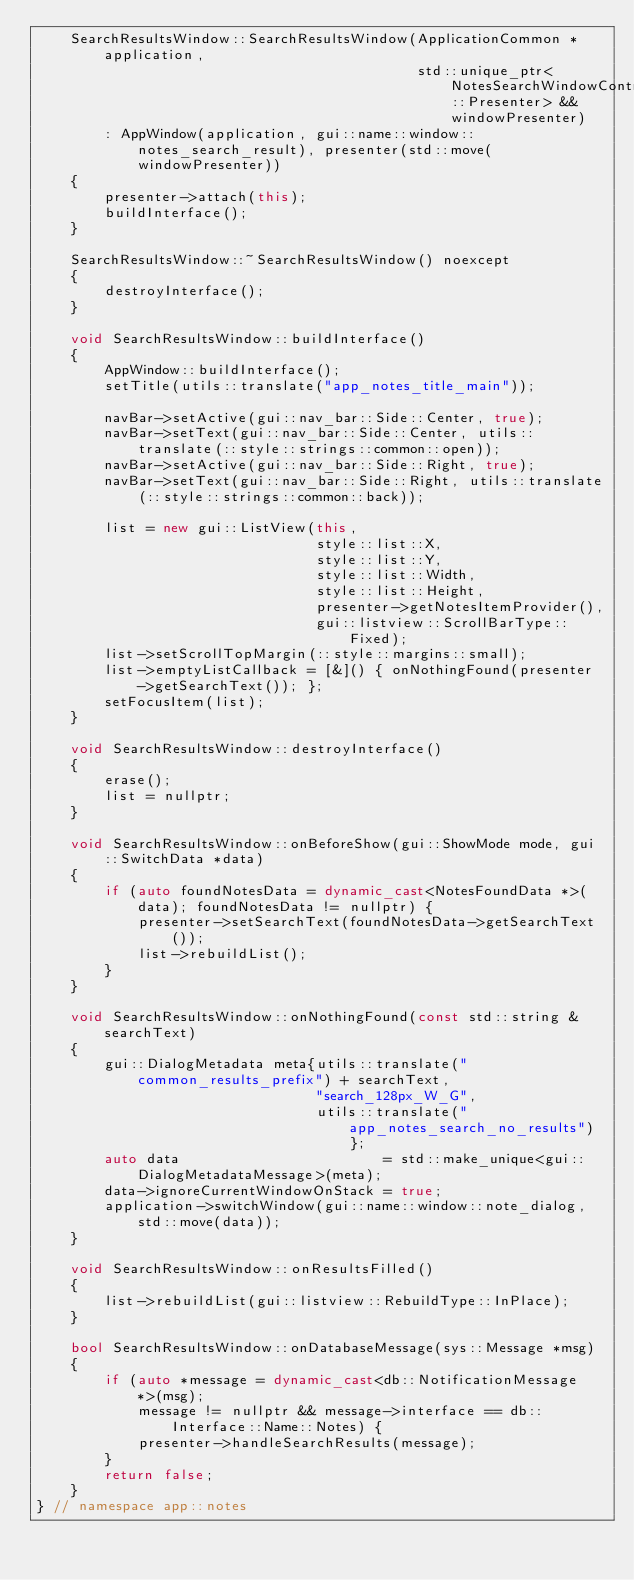Convert code to text. <code><loc_0><loc_0><loc_500><loc_500><_C++_>    SearchResultsWindow::SearchResultsWindow(ApplicationCommon *application,
                                             std::unique_ptr<NotesSearchWindowContract::Presenter> &&windowPresenter)
        : AppWindow(application, gui::name::window::notes_search_result), presenter(std::move(windowPresenter))
    {
        presenter->attach(this);
        buildInterface();
    }

    SearchResultsWindow::~SearchResultsWindow() noexcept
    {
        destroyInterface();
    }

    void SearchResultsWindow::buildInterface()
    {
        AppWindow::buildInterface();
        setTitle(utils::translate("app_notes_title_main"));

        navBar->setActive(gui::nav_bar::Side::Center, true);
        navBar->setText(gui::nav_bar::Side::Center, utils::translate(::style::strings::common::open));
        navBar->setActive(gui::nav_bar::Side::Right, true);
        navBar->setText(gui::nav_bar::Side::Right, utils::translate(::style::strings::common::back));

        list = new gui::ListView(this,
                                 style::list::X,
                                 style::list::Y,
                                 style::list::Width,
                                 style::list::Height,
                                 presenter->getNotesItemProvider(),
                                 gui::listview::ScrollBarType::Fixed);
        list->setScrollTopMargin(::style::margins::small);
        list->emptyListCallback = [&]() { onNothingFound(presenter->getSearchText()); };
        setFocusItem(list);
    }

    void SearchResultsWindow::destroyInterface()
    {
        erase();
        list = nullptr;
    }

    void SearchResultsWindow::onBeforeShow(gui::ShowMode mode, gui::SwitchData *data)
    {
        if (auto foundNotesData = dynamic_cast<NotesFoundData *>(data); foundNotesData != nullptr) {
            presenter->setSearchText(foundNotesData->getSearchText());
            list->rebuildList();
        }
    }

    void SearchResultsWindow::onNothingFound(const std::string &searchText)
    {
        gui::DialogMetadata meta{utils::translate("common_results_prefix") + searchText,
                                 "search_128px_W_G",
                                 utils::translate("app_notes_search_no_results")};
        auto data                        = std::make_unique<gui::DialogMetadataMessage>(meta);
        data->ignoreCurrentWindowOnStack = true;
        application->switchWindow(gui::name::window::note_dialog, std::move(data));
    }

    void SearchResultsWindow::onResultsFilled()
    {
        list->rebuildList(gui::listview::RebuildType::InPlace);
    }

    bool SearchResultsWindow::onDatabaseMessage(sys::Message *msg)
    {
        if (auto *message = dynamic_cast<db::NotificationMessage *>(msg);
            message != nullptr && message->interface == db::Interface::Name::Notes) {
            presenter->handleSearchResults(message);
        }
        return false;
    }
} // namespace app::notes
</code> 